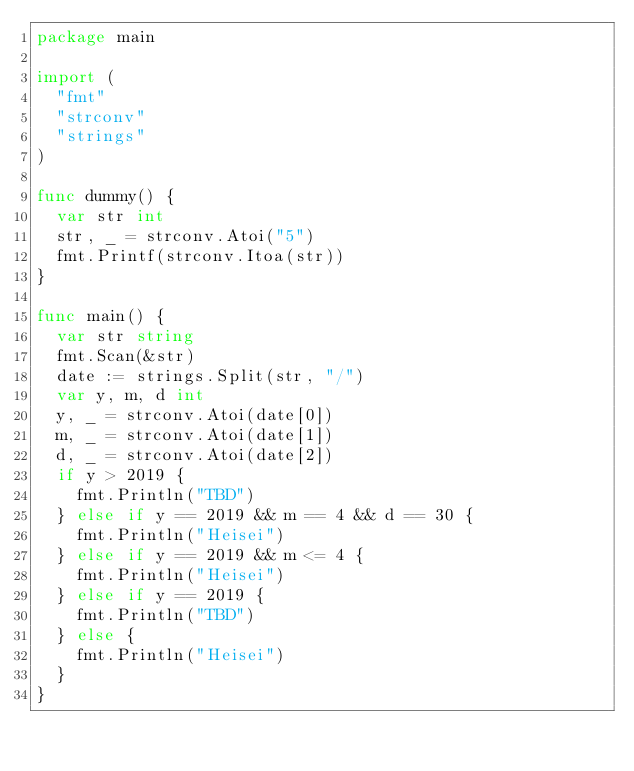<code> <loc_0><loc_0><loc_500><loc_500><_Go_>package main

import (
	"fmt"
	"strconv"
	"strings"
)

func dummy() {
	var str int
	str, _ = strconv.Atoi("5")
	fmt.Printf(strconv.Itoa(str))
}

func main() {
	var str string
	fmt.Scan(&str)
	date := strings.Split(str, "/")
	var y, m, d int
	y, _ = strconv.Atoi(date[0])
	m, _ = strconv.Atoi(date[1])
	d, _ = strconv.Atoi(date[2])
	if y > 2019 {
		fmt.Println("TBD")
	} else if y == 2019 && m == 4 && d == 30 {
		fmt.Println("Heisei")
	} else if y == 2019 && m <= 4 {
		fmt.Println("Heisei")
	} else if y == 2019 {
		fmt.Println("TBD")
	} else {
		fmt.Println("Heisei")
	}
}
</code> 